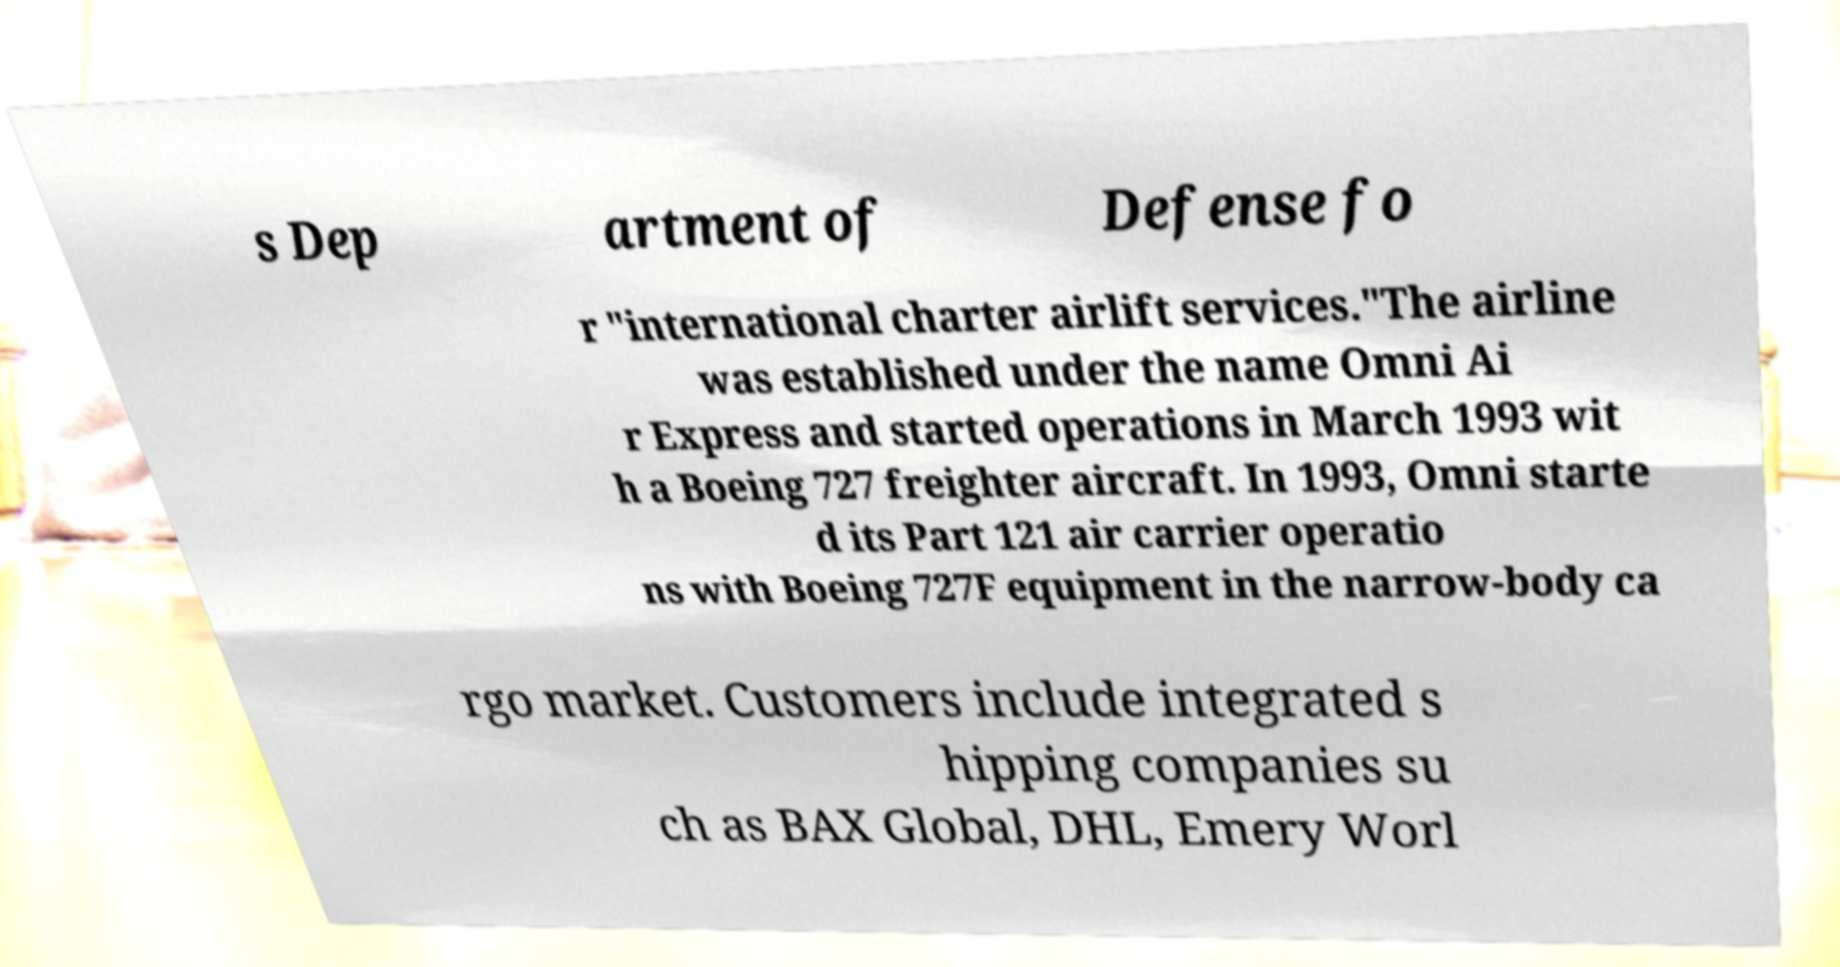I need the written content from this picture converted into text. Can you do that? s Dep artment of Defense fo r "international charter airlift services."The airline was established under the name Omni Ai r Express and started operations in March 1993 wit h a Boeing 727 freighter aircraft. In 1993, Omni starte d its Part 121 air carrier operatio ns with Boeing 727F equipment in the narrow-body ca rgo market. Customers include integrated s hipping companies su ch as BAX Global, DHL, Emery Worl 